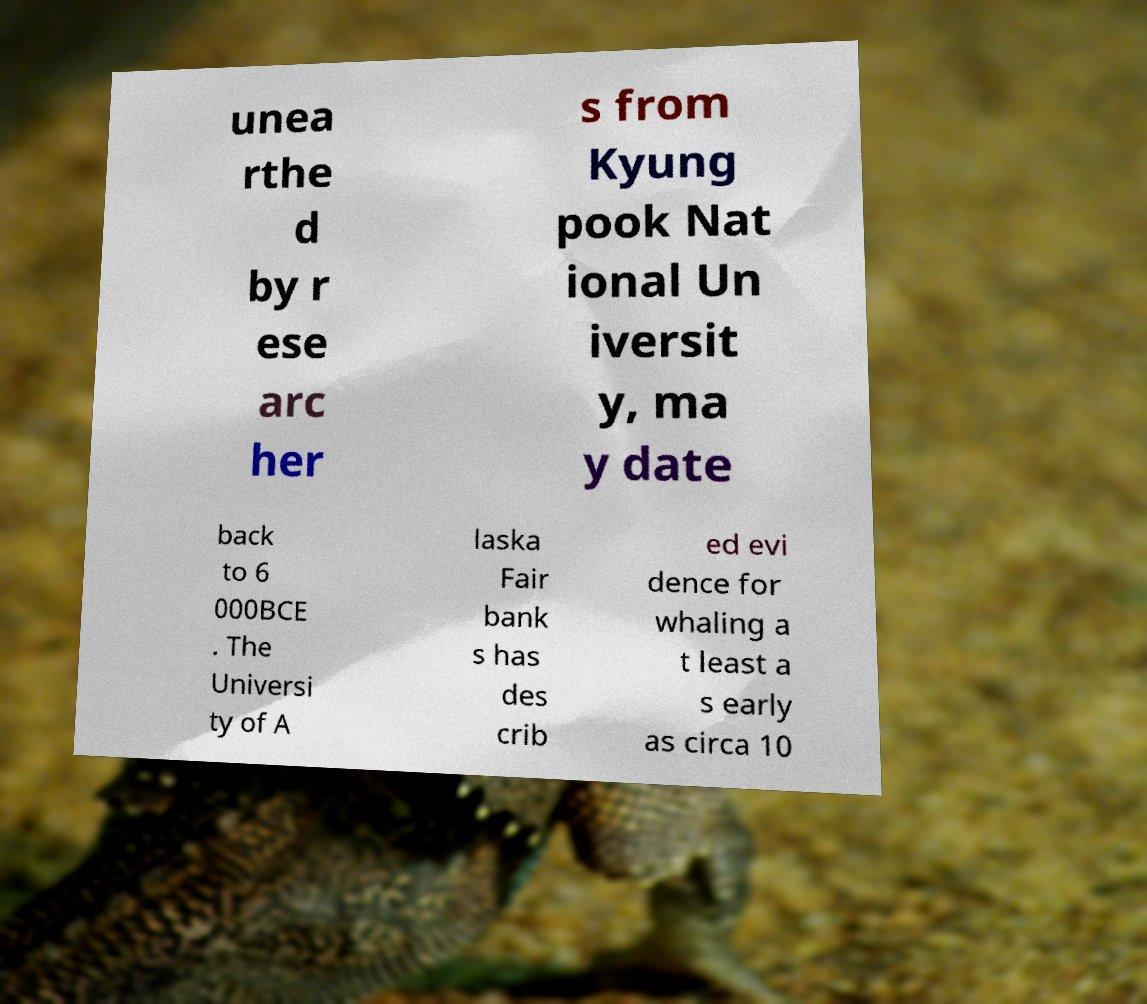Can you read and provide the text displayed in the image?This photo seems to have some interesting text. Can you extract and type it out for me? unea rthe d by r ese arc her s from Kyung pook Nat ional Un iversit y, ma y date back to 6 000BCE . The Universi ty of A laska Fair bank s has des crib ed evi dence for whaling a t least a s early as circa 10 